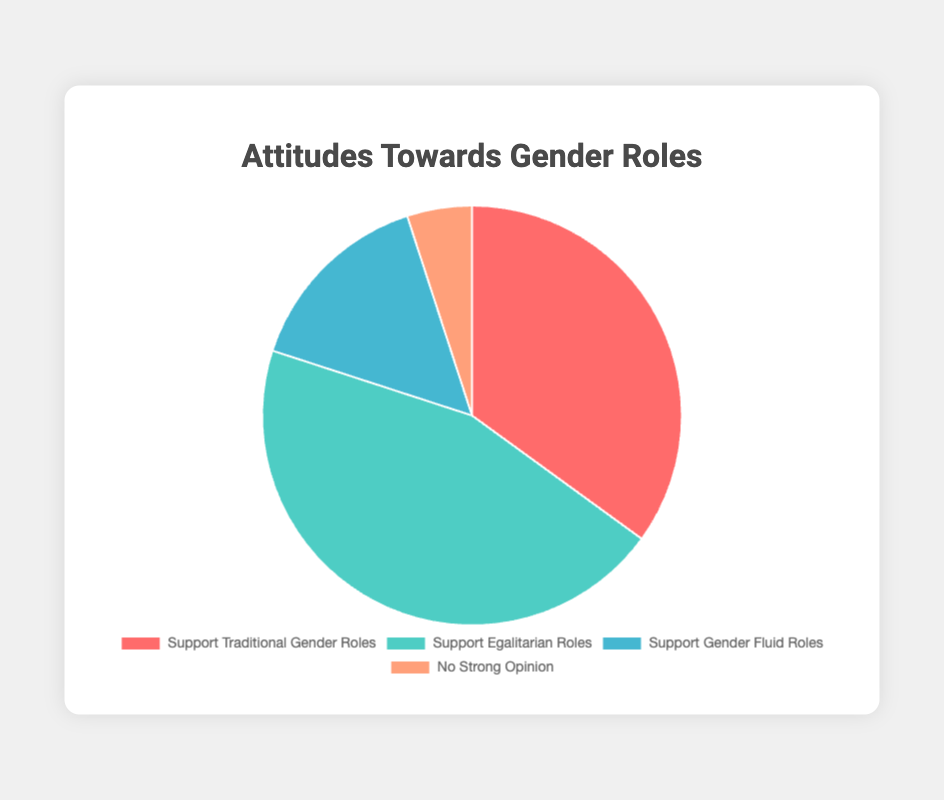What percentage of respondents support traditional gender roles? The slice representing 'Support Traditional Gender Roles' is labeled with a percentage of 35.
Answer: 35% What is the combined percentage of respondents who support egalitarian roles and gender fluid roles? The slice for 'Support Egalitarian Roles' is labeled 45%, and the slice for 'Support Gender Fluid Roles' is labeled 15%. Adding these percentages 45 + 15 equals 60.
Answer: 60% Which segment represents the smallest proportion of respondents? The slice labeled 'No Strong Opinion' is the smallest and has a percentage of 5%. This is smaller compared to the other categories.
Answer: No Strong Opinion How many respondents out of 100 do not support traditional gender roles? The percentage of respondents who support traditional gender roles is 35%. Therefore, the complement of this percentage is 100 - 35, which is 65. This means that 65 out of 100 respondents do not support traditional gender roles.
Answer: 65 What is the ratio of respondents supporting egalitarian roles to those with no strong opinion? The percentage for 'Support Egalitarian Roles' is 45%, and for 'No Strong Opinion' it is 5%. The ratio is calculated by dividing the two, 45/5, which simplifies to 9:1.
Answer: 9:1 Compare the proportion of respondents who support traditional gender roles and gender fluid roles. The percentage for 'Support Traditional Gender Roles' is 35% and for 'Support Gender Fluid Roles' is 15%. Traditional gender roles support is more than double that of gender fluid roles.
Answer: Support Traditional Gender Roles > Support Gender Fluid Roles What is the percentage difference between those who support traditional gender roles and those who support gender fluid roles? The percentage for 'Support Traditional Gender Roles' is 35%, and for 'Support Gender Fluid Roles' is 15%. The difference is 35 - 15, which equals 20%.
Answer: 20% Is the proportion of respondents with no strong opinion more or less than one-fifth of the proportion of traditional gender role supporters? One-fifth of 35% (Support Traditional Gender Roles) is 7%. Since 'No Strong Opinion' is 5%, which is less than 7%, the proportion with no strong opinion is less than one-fifth of those supporting traditional gender roles.
Answer: Less How much more do supporters of egalitarian roles represent compared to those with no strong opinion? The proportion supporting egalitarian roles is 45%, and those with no strong opinion is 5%. The difference between them is 45 - 5, which is 40%.
Answer: 40% What is the visual color representing 'Support Gender Fluid Roles'? The slice for 'Support Gender Fluid Roles' is visually represented by the color light blue.
Answer: Light blue 